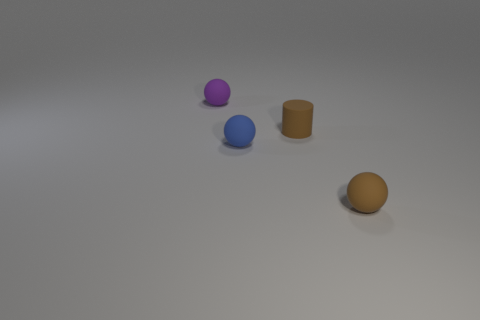Add 3 brown objects. How many objects exist? 7 Subtract all balls. How many objects are left? 1 Subtract all brown matte cylinders. Subtract all tiny brown things. How many objects are left? 1 Add 1 purple objects. How many purple objects are left? 2 Add 4 big purple shiny spheres. How many big purple shiny spheres exist? 4 Subtract 1 brown cylinders. How many objects are left? 3 